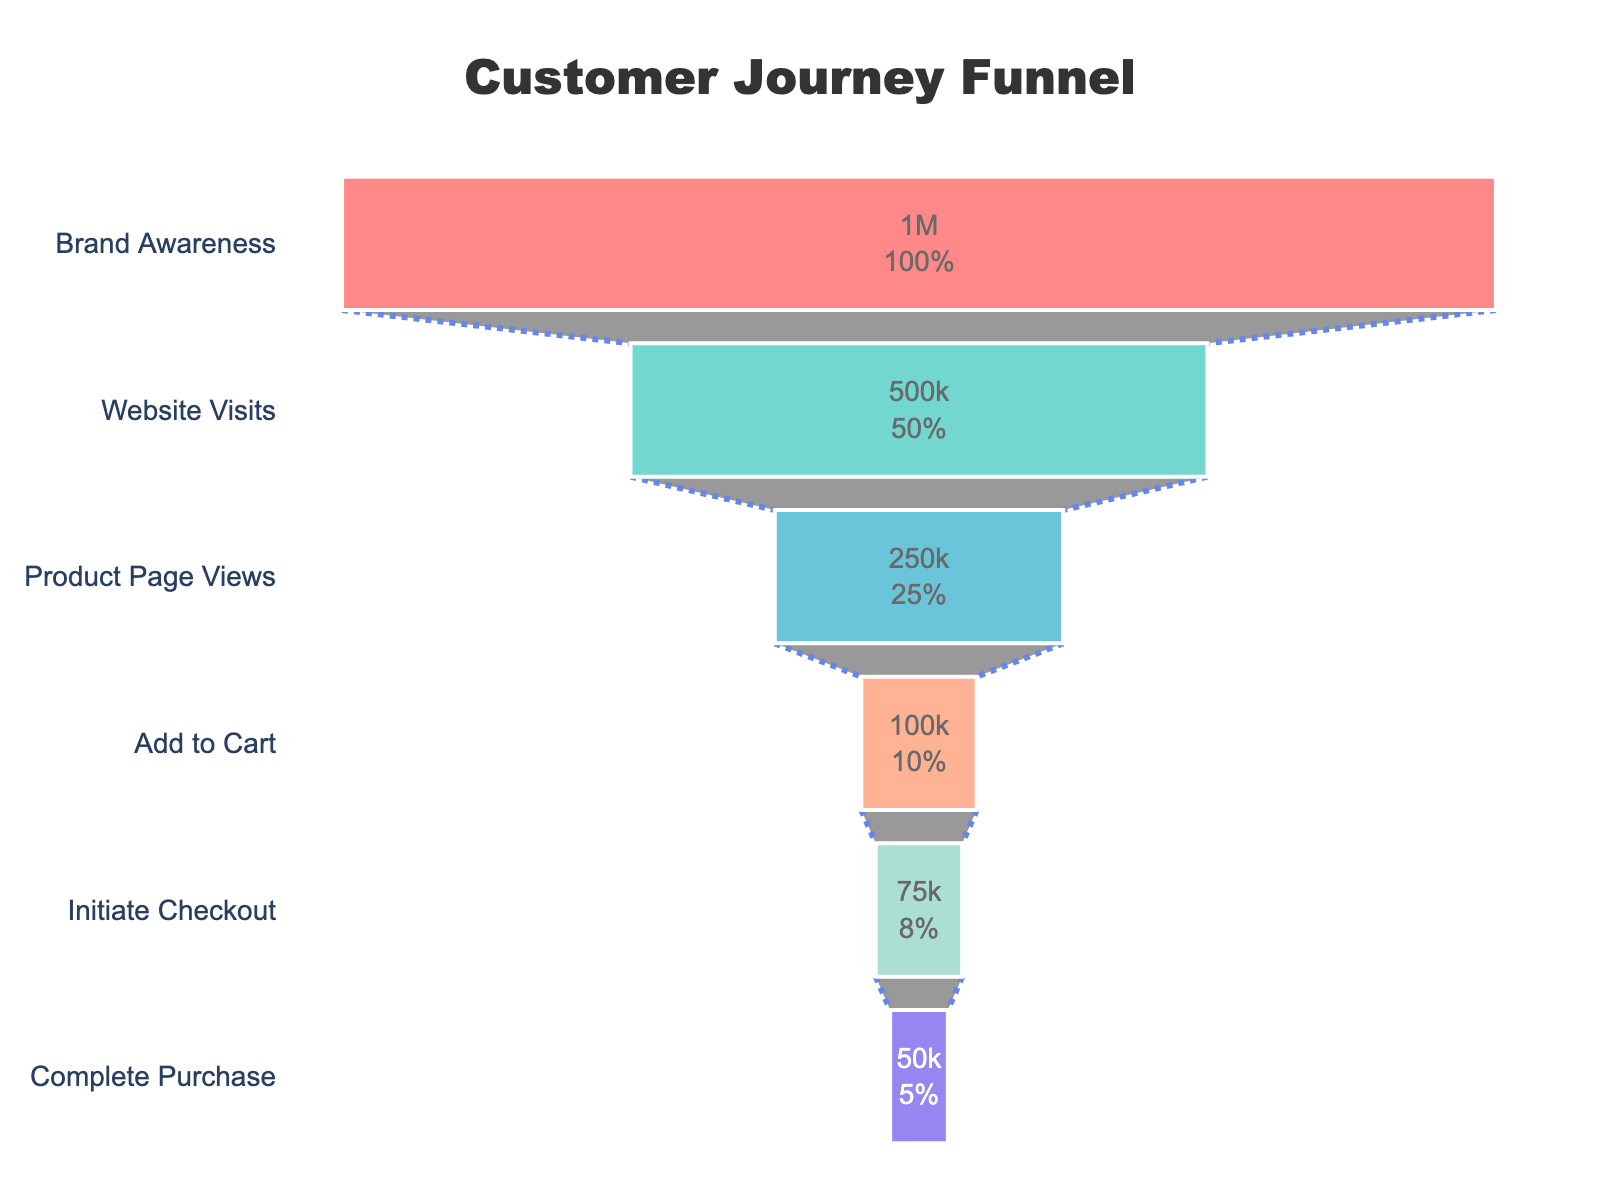What is the title of the funnel chart? At the top of the chart, in a larger and bold font, the title "Customer Journey Funnel" is displayed.
Answer: Customer Journey Funnel How many stages are in the funnel? The stages are listed along the y-axis. There are six stages: Brand Awareness, Website Visits, Product Page Views, Add to Cart, Initiate Checkout, and Complete Purchase.
Answer: Six What percentage of users make it to the 'Initiate Checkout' stage? The 'Initiate Checkout' stage shows a percentage value of 7.5% (calculated as 75,000 / 1,000,000 * 100). This value is derived from the number of users at this stage divided by the initial number of users.
Answer: 7.5% How many users view the product page but do not add to the cart? To find this, calculate the difference between the 'Product Page Views' and 'Add to Cart' stages. Product Page Views has 250,000 users and Add to Cart has 100,000 users, so the difference is 250,000 - 100,000.
Answer: 150,000 What's the conversion rate from 'Website Visits' to 'Product Page Views'? Calculate the conversion rate by dividing the number of users at the 'Product Page Views' stage by the number at the 'Website Visits' stage. This ratio is 250,000 / 500,000, resulting in 50%.
Answer: 50% Which stage shows the largest drop in user count? By checking the user counts, the largest drop occurs between the 'Website Visits' (500,000) and 'Product Page Views' (250,000). The difference is 250,000 users.
Answer: Website Visits to Product Page Views How many users do not proceed from 'Brand Awareness' to 'Website Visits'? Subtract the number of users at 'Website Visits' from 'Brand Awareness': 1,000,000 - 500,000 = 500,000 users.
Answer: 500,000 What's the transition rate from 'Add to Cart' to 'Complete Purchase'? To determine the transition rate, divide the number of users at 'Complete Purchase' (50,000) by the number at 'Add to Cart' (100,000): 50,000 / 100,000 = 50%.
Answer: 50% Which stage has half the users of the 'Brand Awareness' stage? The 'Website Visits' stage has 500,000 users, which is exactly half of the 1,000,000 users at the 'Brand Awareness' stage.
Answer: Website Visits What is the user dropout rate between 'Initiate Checkout' and 'Complete Purchase'? Subtract the users at 'Complete Purchase' from 'Initiate Checkout': 75,000 - 50,000 = 25,000. To get the percentage, divide by 'Initiate Checkout' users and multiply by 100: (25,000 / 75,000) * 100 = 33.33%.
Answer: 33.33% 